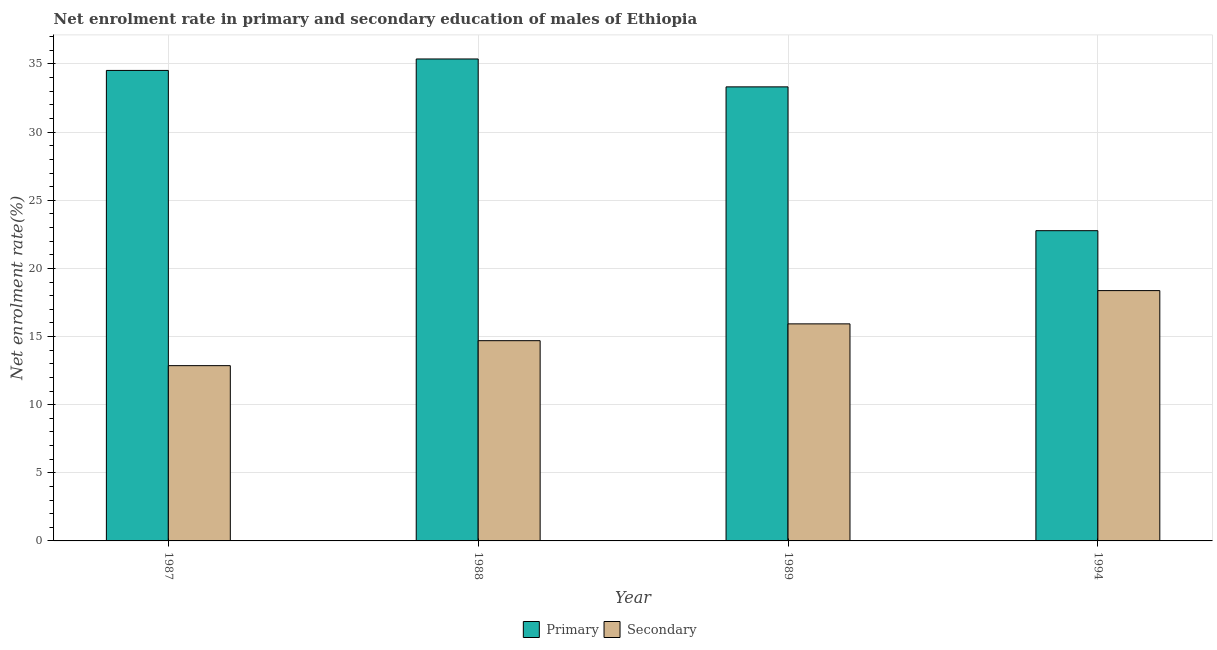How many groups of bars are there?
Offer a very short reply. 4. Are the number of bars per tick equal to the number of legend labels?
Provide a succinct answer. Yes. What is the enrollment rate in primary education in 1994?
Make the answer very short. 22.77. Across all years, what is the maximum enrollment rate in secondary education?
Give a very brief answer. 18.37. Across all years, what is the minimum enrollment rate in primary education?
Keep it short and to the point. 22.77. What is the total enrollment rate in primary education in the graph?
Provide a succinct answer. 125.99. What is the difference between the enrollment rate in primary education in 1987 and that in 1994?
Offer a very short reply. 11.76. What is the difference between the enrollment rate in primary education in 1988 and the enrollment rate in secondary education in 1987?
Offer a terse response. 0.84. What is the average enrollment rate in primary education per year?
Provide a succinct answer. 31.5. In the year 1988, what is the difference between the enrollment rate in primary education and enrollment rate in secondary education?
Keep it short and to the point. 0. In how many years, is the enrollment rate in secondary education greater than 23 %?
Provide a succinct answer. 0. What is the ratio of the enrollment rate in secondary education in 1987 to that in 1994?
Provide a short and direct response. 0.7. Is the enrollment rate in primary education in 1988 less than that in 1989?
Your response must be concise. No. Is the difference between the enrollment rate in secondary education in 1988 and 1989 greater than the difference between the enrollment rate in primary education in 1988 and 1989?
Give a very brief answer. No. What is the difference between the highest and the second highest enrollment rate in secondary education?
Offer a terse response. 2.44. What is the difference between the highest and the lowest enrollment rate in secondary education?
Make the answer very short. 5.51. Is the sum of the enrollment rate in secondary education in 1989 and 1994 greater than the maximum enrollment rate in primary education across all years?
Provide a short and direct response. Yes. What does the 2nd bar from the left in 1994 represents?
Your response must be concise. Secondary. What does the 2nd bar from the right in 1989 represents?
Offer a very short reply. Primary. Are all the bars in the graph horizontal?
Provide a short and direct response. No. How many years are there in the graph?
Offer a very short reply. 4. What is the difference between two consecutive major ticks on the Y-axis?
Offer a terse response. 5. Where does the legend appear in the graph?
Offer a very short reply. Bottom center. How many legend labels are there?
Provide a succinct answer. 2. How are the legend labels stacked?
Provide a succinct answer. Horizontal. What is the title of the graph?
Keep it short and to the point. Net enrolment rate in primary and secondary education of males of Ethiopia. What is the label or title of the Y-axis?
Your response must be concise. Net enrolment rate(%). What is the Net enrolment rate(%) in Primary in 1987?
Offer a very short reply. 34.53. What is the Net enrolment rate(%) in Secondary in 1987?
Ensure brevity in your answer.  12.86. What is the Net enrolment rate(%) of Primary in 1988?
Provide a succinct answer. 35.37. What is the Net enrolment rate(%) of Secondary in 1988?
Ensure brevity in your answer.  14.7. What is the Net enrolment rate(%) of Primary in 1989?
Your answer should be very brief. 33.32. What is the Net enrolment rate(%) of Secondary in 1989?
Make the answer very short. 15.93. What is the Net enrolment rate(%) in Primary in 1994?
Make the answer very short. 22.77. What is the Net enrolment rate(%) in Secondary in 1994?
Ensure brevity in your answer.  18.37. Across all years, what is the maximum Net enrolment rate(%) in Primary?
Make the answer very short. 35.37. Across all years, what is the maximum Net enrolment rate(%) of Secondary?
Offer a very short reply. 18.37. Across all years, what is the minimum Net enrolment rate(%) of Primary?
Ensure brevity in your answer.  22.77. Across all years, what is the minimum Net enrolment rate(%) in Secondary?
Your answer should be compact. 12.86. What is the total Net enrolment rate(%) of Primary in the graph?
Your response must be concise. 125.99. What is the total Net enrolment rate(%) of Secondary in the graph?
Provide a short and direct response. 61.86. What is the difference between the Net enrolment rate(%) of Primary in 1987 and that in 1988?
Your response must be concise. -0.84. What is the difference between the Net enrolment rate(%) of Secondary in 1987 and that in 1988?
Ensure brevity in your answer.  -1.83. What is the difference between the Net enrolment rate(%) of Primary in 1987 and that in 1989?
Provide a short and direct response. 1.21. What is the difference between the Net enrolment rate(%) in Secondary in 1987 and that in 1989?
Provide a succinct answer. -3.07. What is the difference between the Net enrolment rate(%) in Primary in 1987 and that in 1994?
Make the answer very short. 11.76. What is the difference between the Net enrolment rate(%) of Secondary in 1987 and that in 1994?
Your response must be concise. -5.51. What is the difference between the Net enrolment rate(%) in Primary in 1988 and that in 1989?
Offer a terse response. 2.05. What is the difference between the Net enrolment rate(%) in Secondary in 1988 and that in 1989?
Your answer should be compact. -1.23. What is the difference between the Net enrolment rate(%) of Primary in 1988 and that in 1994?
Make the answer very short. 12.6. What is the difference between the Net enrolment rate(%) of Secondary in 1988 and that in 1994?
Your answer should be very brief. -3.68. What is the difference between the Net enrolment rate(%) in Primary in 1989 and that in 1994?
Offer a terse response. 10.55. What is the difference between the Net enrolment rate(%) of Secondary in 1989 and that in 1994?
Your answer should be compact. -2.44. What is the difference between the Net enrolment rate(%) of Primary in 1987 and the Net enrolment rate(%) of Secondary in 1988?
Offer a very short reply. 19.83. What is the difference between the Net enrolment rate(%) of Primary in 1987 and the Net enrolment rate(%) of Secondary in 1989?
Provide a short and direct response. 18.6. What is the difference between the Net enrolment rate(%) of Primary in 1987 and the Net enrolment rate(%) of Secondary in 1994?
Give a very brief answer. 16.16. What is the difference between the Net enrolment rate(%) of Primary in 1988 and the Net enrolment rate(%) of Secondary in 1989?
Make the answer very short. 19.44. What is the difference between the Net enrolment rate(%) of Primary in 1988 and the Net enrolment rate(%) of Secondary in 1994?
Offer a very short reply. 17. What is the difference between the Net enrolment rate(%) in Primary in 1989 and the Net enrolment rate(%) in Secondary in 1994?
Keep it short and to the point. 14.95. What is the average Net enrolment rate(%) of Primary per year?
Give a very brief answer. 31.5. What is the average Net enrolment rate(%) of Secondary per year?
Offer a terse response. 15.46. In the year 1987, what is the difference between the Net enrolment rate(%) in Primary and Net enrolment rate(%) in Secondary?
Provide a short and direct response. 21.66. In the year 1988, what is the difference between the Net enrolment rate(%) in Primary and Net enrolment rate(%) in Secondary?
Your response must be concise. 20.67. In the year 1989, what is the difference between the Net enrolment rate(%) in Primary and Net enrolment rate(%) in Secondary?
Offer a terse response. 17.39. In the year 1994, what is the difference between the Net enrolment rate(%) in Primary and Net enrolment rate(%) in Secondary?
Your answer should be compact. 4.4. What is the ratio of the Net enrolment rate(%) in Primary in 1987 to that in 1988?
Your response must be concise. 0.98. What is the ratio of the Net enrolment rate(%) in Secondary in 1987 to that in 1988?
Your response must be concise. 0.88. What is the ratio of the Net enrolment rate(%) of Primary in 1987 to that in 1989?
Ensure brevity in your answer.  1.04. What is the ratio of the Net enrolment rate(%) of Secondary in 1987 to that in 1989?
Make the answer very short. 0.81. What is the ratio of the Net enrolment rate(%) of Primary in 1987 to that in 1994?
Keep it short and to the point. 1.52. What is the ratio of the Net enrolment rate(%) of Secondary in 1987 to that in 1994?
Keep it short and to the point. 0.7. What is the ratio of the Net enrolment rate(%) of Primary in 1988 to that in 1989?
Provide a short and direct response. 1.06. What is the ratio of the Net enrolment rate(%) of Secondary in 1988 to that in 1989?
Ensure brevity in your answer.  0.92. What is the ratio of the Net enrolment rate(%) in Primary in 1988 to that in 1994?
Your answer should be compact. 1.55. What is the ratio of the Net enrolment rate(%) in Secondary in 1988 to that in 1994?
Give a very brief answer. 0.8. What is the ratio of the Net enrolment rate(%) of Primary in 1989 to that in 1994?
Keep it short and to the point. 1.46. What is the ratio of the Net enrolment rate(%) of Secondary in 1989 to that in 1994?
Ensure brevity in your answer.  0.87. What is the difference between the highest and the second highest Net enrolment rate(%) of Primary?
Offer a very short reply. 0.84. What is the difference between the highest and the second highest Net enrolment rate(%) in Secondary?
Your answer should be compact. 2.44. What is the difference between the highest and the lowest Net enrolment rate(%) of Primary?
Provide a short and direct response. 12.6. What is the difference between the highest and the lowest Net enrolment rate(%) in Secondary?
Ensure brevity in your answer.  5.51. 